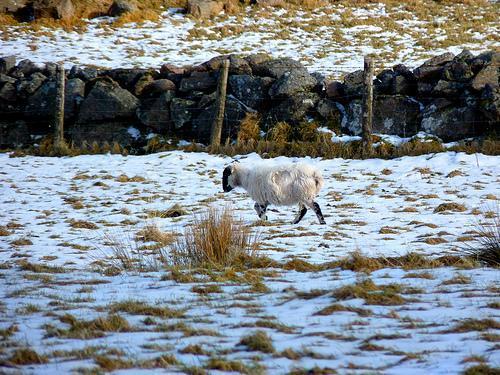How many goats are pictured?
Give a very brief answer. 1. 